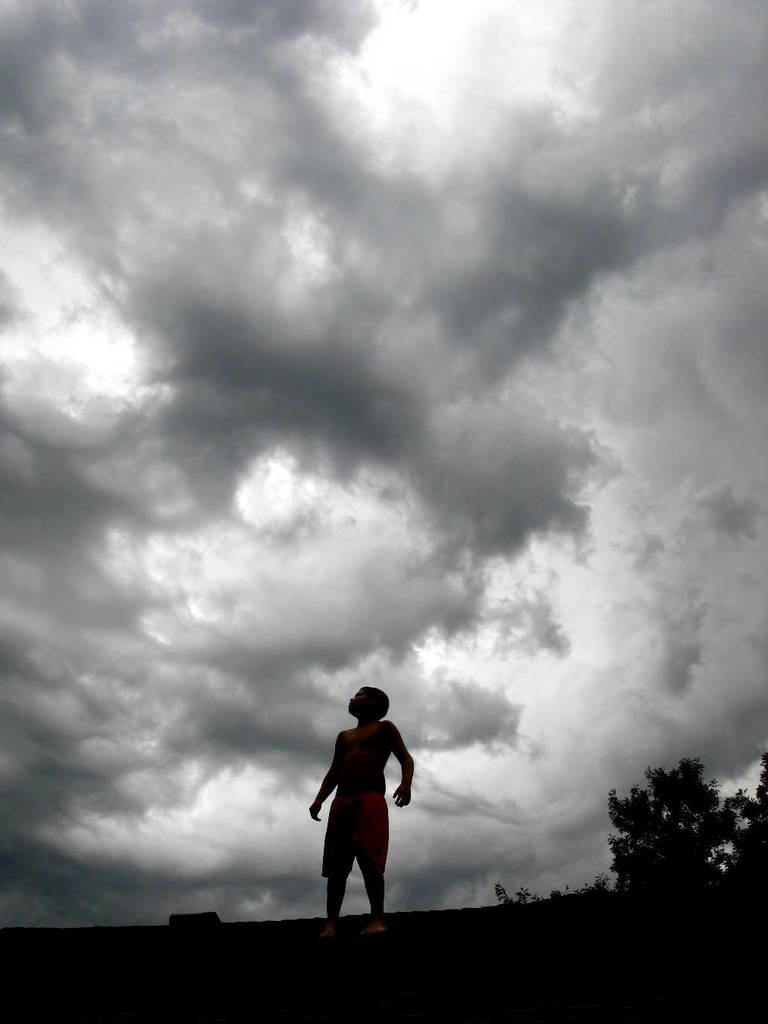What is the main subject in the front of the image? There is a boy standing in the front of the image. What can be seen beside the boy? There are trees beside the boy. What is the condition of the sky in the image? The sky is cloudy and visible in the image. What type of horn can be heard in the background of the image? There is no horn present in the image, and therefore no sound can be heard. 